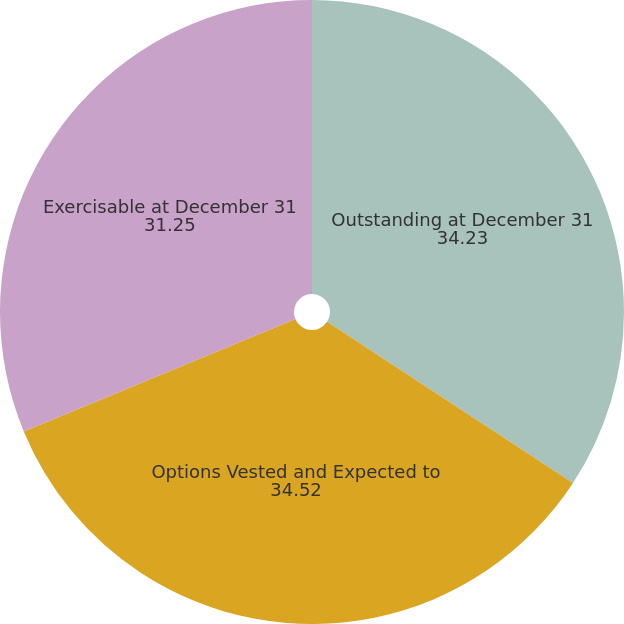<chart> <loc_0><loc_0><loc_500><loc_500><pie_chart><fcel>Outstanding at December 31<fcel>Options Vested and Expected to<fcel>Exercisable at December 31<nl><fcel>34.23%<fcel>34.52%<fcel>31.25%<nl></chart> 